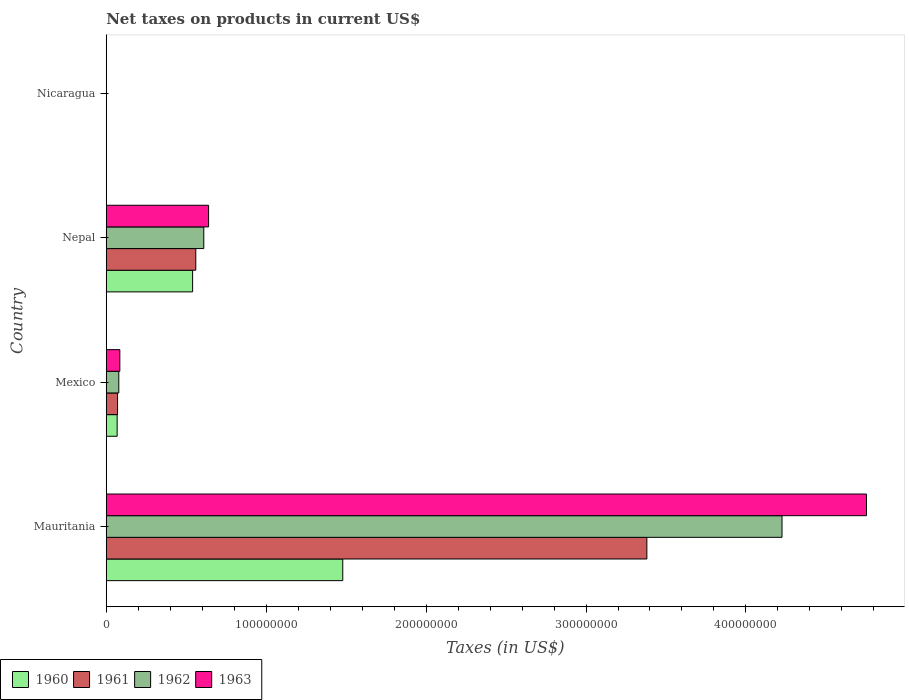How many different coloured bars are there?
Ensure brevity in your answer.  4. How many groups of bars are there?
Provide a short and direct response. 4. Are the number of bars on each tick of the Y-axis equal?
Your answer should be compact. Yes. How many bars are there on the 2nd tick from the bottom?
Offer a terse response. 4. What is the label of the 4th group of bars from the top?
Provide a succinct answer. Mauritania. What is the net taxes on products in 1962 in Nepal?
Offer a very short reply. 6.10e+07. Across all countries, what is the maximum net taxes on products in 1963?
Your answer should be compact. 4.75e+08. Across all countries, what is the minimum net taxes on products in 1963?
Ensure brevity in your answer.  0.04. In which country was the net taxes on products in 1961 maximum?
Provide a succinct answer. Mauritania. In which country was the net taxes on products in 1961 minimum?
Provide a succinct answer. Nicaragua. What is the total net taxes on products in 1962 in the graph?
Keep it short and to the point. 4.91e+08. What is the difference between the net taxes on products in 1960 in Mauritania and that in Mexico?
Make the answer very short. 1.41e+08. What is the difference between the net taxes on products in 1963 in Mauritania and the net taxes on products in 1961 in Nepal?
Offer a very short reply. 4.19e+08. What is the average net taxes on products in 1961 per country?
Your response must be concise. 1.00e+08. What is the difference between the net taxes on products in 1961 and net taxes on products in 1960 in Mauritania?
Make the answer very short. 1.90e+08. In how many countries, is the net taxes on products in 1963 greater than 240000000 US$?
Keep it short and to the point. 1. What is the ratio of the net taxes on products in 1963 in Mauritania to that in Nicaragua?
Offer a very short reply. 1.14e+1. Is the net taxes on products in 1963 in Mexico less than that in Nepal?
Provide a short and direct response. Yes. Is the difference between the net taxes on products in 1961 in Mexico and Nicaragua greater than the difference between the net taxes on products in 1960 in Mexico and Nicaragua?
Keep it short and to the point. Yes. What is the difference between the highest and the second highest net taxes on products in 1960?
Your answer should be very brief. 9.39e+07. What is the difference between the highest and the lowest net taxes on products in 1961?
Your answer should be compact. 3.38e+08. Is the sum of the net taxes on products in 1961 in Mexico and Nicaragua greater than the maximum net taxes on products in 1963 across all countries?
Offer a terse response. No. What does the 4th bar from the bottom in Mauritania represents?
Ensure brevity in your answer.  1963. How many countries are there in the graph?
Provide a short and direct response. 4. What is the difference between two consecutive major ticks on the X-axis?
Keep it short and to the point. 1.00e+08. Are the values on the major ticks of X-axis written in scientific E-notation?
Offer a terse response. No. Where does the legend appear in the graph?
Your answer should be compact. Bottom left. How are the legend labels stacked?
Offer a terse response. Horizontal. What is the title of the graph?
Keep it short and to the point. Net taxes on products in current US$. What is the label or title of the X-axis?
Provide a succinct answer. Taxes (in US$). What is the Taxes (in US$) in 1960 in Mauritania?
Keep it short and to the point. 1.48e+08. What is the Taxes (in US$) of 1961 in Mauritania?
Offer a terse response. 3.38e+08. What is the Taxes (in US$) of 1962 in Mauritania?
Give a very brief answer. 4.23e+08. What is the Taxes (in US$) of 1963 in Mauritania?
Provide a short and direct response. 4.75e+08. What is the Taxes (in US$) in 1960 in Mexico?
Provide a succinct answer. 6.81e+06. What is the Taxes (in US$) in 1961 in Mexico?
Give a very brief answer. 7.08e+06. What is the Taxes (in US$) in 1962 in Mexico?
Offer a terse response. 7.85e+06. What is the Taxes (in US$) in 1963 in Mexico?
Ensure brevity in your answer.  8.49e+06. What is the Taxes (in US$) of 1960 in Nepal?
Keep it short and to the point. 5.40e+07. What is the Taxes (in US$) in 1961 in Nepal?
Your response must be concise. 5.60e+07. What is the Taxes (in US$) in 1962 in Nepal?
Keep it short and to the point. 6.10e+07. What is the Taxes (in US$) of 1963 in Nepal?
Your response must be concise. 6.40e+07. What is the Taxes (in US$) of 1960 in Nicaragua?
Ensure brevity in your answer.  0.03. What is the Taxes (in US$) of 1961 in Nicaragua?
Offer a very short reply. 0.03. What is the Taxes (in US$) of 1962 in Nicaragua?
Provide a succinct answer. 0.04. What is the Taxes (in US$) of 1963 in Nicaragua?
Keep it short and to the point. 0.04. Across all countries, what is the maximum Taxes (in US$) of 1960?
Offer a terse response. 1.48e+08. Across all countries, what is the maximum Taxes (in US$) in 1961?
Offer a terse response. 3.38e+08. Across all countries, what is the maximum Taxes (in US$) of 1962?
Ensure brevity in your answer.  4.23e+08. Across all countries, what is the maximum Taxes (in US$) of 1963?
Keep it short and to the point. 4.75e+08. Across all countries, what is the minimum Taxes (in US$) of 1960?
Your response must be concise. 0.03. Across all countries, what is the minimum Taxes (in US$) of 1961?
Ensure brevity in your answer.  0.03. Across all countries, what is the minimum Taxes (in US$) of 1962?
Your response must be concise. 0.04. Across all countries, what is the minimum Taxes (in US$) of 1963?
Offer a very short reply. 0.04. What is the total Taxes (in US$) in 1960 in the graph?
Ensure brevity in your answer.  2.09e+08. What is the total Taxes (in US$) in 1961 in the graph?
Offer a terse response. 4.01e+08. What is the total Taxes (in US$) in 1962 in the graph?
Your answer should be very brief. 4.91e+08. What is the total Taxes (in US$) in 1963 in the graph?
Ensure brevity in your answer.  5.48e+08. What is the difference between the Taxes (in US$) of 1960 in Mauritania and that in Mexico?
Offer a terse response. 1.41e+08. What is the difference between the Taxes (in US$) in 1961 in Mauritania and that in Mexico?
Your answer should be compact. 3.31e+08. What is the difference between the Taxes (in US$) of 1962 in Mauritania and that in Mexico?
Your answer should be compact. 4.15e+08. What is the difference between the Taxes (in US$) of 1963 in Mauritania and that in Mexico?
Keep it short and to the point. 4.67e+08. What is the difference between the Taxes (in US$) of 1960 in Mauritania and that in Nepal?
Provide a succinct answer. 9.39e+07. What is the difference between the Taxes (in US$) in 1961 in Mauritania and that in Nepal?
Keep it short and to the point. 2.82e+08. What is the difference between the Taxes (in US$) in 1962 in Mauritania and that in Nepal?
Keep it short and to the point. 3.62e+08. What is the difference between the Taxes (in US$) of 1963 in Mauritania and that in Nepal?
Offer a very short reply. 4.11e+08. What is the difference between the Taxes (in US$) in 1960 in Mauritania and that in Nicaragua?
Provide a succinct answer. 1.48e+08. What is the difference between the Taxes (in US$) of 1961 in Mauritania and that in Nicaragua?
Provide a succinct answer. 3.38e+08. What is the difference between the Taxes (in US$) in 1962 in Mauritania and that in Nicaragua?
Your answer should be compact. 4.23e+08. What is the difference between the Taxes (in US$) of 1963 in Mauritania and that in Nicaragua?
Keep it short and to the point. 4.75e+08. What is the difference between the Taxes (in US$) of 1960 in Mexico and that in Nepal?
Offer a very short reply. -4.72e+07. What is the difference between the Taxes (in US$) of 1961 in Mexico and that in Nepal?
Provide a short and direct response. -4.89e+07. What is the difference between the Taxes (in US$) of 1962 in Mexico and that in Nepal?
Make the answer very short. -5.32e+07. What is the difference between the Taxes (in US$) in 1963 in Mexico and that in Nepal?
Provide a succinct answer. -5.55e+07. What is the difference between the Taxes (in US$) in 1960 in Mexico and that in Nicaragua?
Provide a short and direct response. 6.81e+06. What is the difference between the Taxes (in US$) in 1961 in Mexico and that in Nicaragua?
Make the answer very short. 7.08e+06. What is the difference between the Taxes (in US$) of 1962 in Mexico and that in Nicaragua?
Ensure brevity in your answer.  7.85e+06. What is the difference between the Taxes (in US$) of 1963 in Mexico and that in Nicaragua?
Your response must be concise. 8.49e+06. What is the difference between the Taxes (in US$) of 1960 in Nepal and that in Nicaragua?
Provide a succinct answer. 5.40e+07. What is the difference between the Taxes (in US$) in 1961 in Nepal and that in Nicaragua?
Provide a succinct answer. 5.60e+07. What is the difference between the Taxes (in US$) in 1962 in Nepal and that in Nicaragua?
Keep it short and to the point. 6.10e+07. What is the difference between the Taxes (in US$) of 1963 in Nepal and that in Nicaragua?
Your answer should be very brief. 6.40e+07. What is the difference between the Taxes (in US$) in 1960 in Mauritania and the Taxes (in US$) in 1961 in Mexico?
Provide a short and direct response. 1.41e+08. What is the difference between the Taxes (in US$) in 1960 in Mauritania and the Taxes (in US$) in 1962 in Mexico?
Your response must be concise. 1.40e+08. What is the difference between the Taxes (in US$) in 1960 in Mauritania and the Taxes (in US$) in 1963 in Mexico?
Your response must be concise. 1.39e+08. What is the difference between the Taxes (in US$) of 1961 in Mauritania and the Taxes (in US$) of 1962 in Mexico?
Your response must be concise. 3.30e+08. What is the difference between the Taxes (in US$) of 1961 in Mauritania and the Taxes (in US$) of 1963 in Mexico?
Offer a very short reply. 3.30e+08. What is the difference between the Taxes (in US$) in 1962 in Mauritania and the Taxes (in US$) in 1963 in Mexico?
Your answer should be compact. 4.14e+08. What is the difference between the Taxes (in US$) in 1960 in Mauritania and the Taxes (in US$) in 1961 in Nepal?
Give a very brief answer. 9.19e+07. What is the difference between the Taxes (in US$) of 1960 in Mauritania and the Taxes (in US$) of 1962 in Nepal?
Your answer should be compact. 8.69e+07. What is the difference between the Taxes (in US$) in 1960 in Mauritania and the Taxes (in US$) in 1963 in Nepal?
Make the answer very short. 8.39e+07. What is the difference between the Taxes (in US$) of 1961 in Mauritania and the Taxes (in US$) of 1962 in Nepal?
Your response must be concise. 2.77e+08. What is the difference between the Taxes (in US$) of 1961 in Mauritania and the Taxes (in US$) of 1963 in Nepal?
Provide a succinct answer. 2.74e+08. What is the difference between the Taxes (in US$) of 1962 in Mauritania and the Taxes (in US$) of 1963 in Nepal?
Give a very brief answer. 3.59e+08. What is the difference between the Taxes (in US$) in 1960 in Mauritania and the Taxes (in US$) in 1961 in Nicaragua?
Keep it short and to the point. 1.48e+08. What is the difference between the Taxes (in US$) in 1960 in Mauritania and the Taxes (in US$) in 1962 in Nicaragua?
Keep it short and to the point. 1.48e+08. What is the difference between the Taxes (in US$) in 1960 in Mauritania and the Taxes (in US$) in 1963 in Nicaragua?
Your answer should be very brief. 1.48e+08. What is the difference between the Taxes (in US$) of 1961 in Mauritania and the Taxes (in US$) of 1962 in Nicaragua?
Give a very brief answer. 3.38e+08. What is the difference between the Taxes (in US$) of 1961 in Mauritania and the Taxes (in US$) of 1963 in Nicaragua?
Your answer should be very brief. 3.38e+08. What is the difference between the Taxes (in US$) of 1962 in Mauritania and the Taxes (in US$) of 1963 in Nicaragua?
Offer a very short reply. 4.23e+08. What is the difference between the Taxes (in US$) of 1960 in Mexico and the Taxes (in US$) of 1961 in Nepal?
Ensure brevity in your answer.  -4.92e+07. What is the difference between the Taxes (in US$) of 1960 in Mexico and the Taxes (in US$) of 1962 in Nepal?
Your response must be concise. -5.42e+07. What is the difference between the Taxes (in US$) of 1960 in Mexico and the Taxes (in US$) of 1963 in Nepal?
Provide a succinct answer. -5.72e+07. What is the difference between the Taxes (in US$) of 1961 in Mexico and the Taxes (in US$) of 1962 in Nepal?
Provide a short and direct response. -5.39e+07. What is the difference between the Taxes (in US$) in 1961 in Mexico and the Taxes (in US$) in 1963 in Nepal?
Make the answer very short. -5.69e+07. What is the difference between the Taxes (in US$) in 1962 in Mexico and the Taxes (in US$) in 1963 in Nepal?
Provide a short and direct response. -5.62e+07. What is the difference between the Taxes (in US$) in 1960 in Mexico and the Taxes (in US$) in 1961 in Nicaragua?
Provide a short and direct response. 6.81e+06. What is the difference between the Taxes (in US$) of 1960 in Mexico and the Taxes (in US$) of 1962 in Nicaragua?
Ensure brevity in your answer.  6.81e+06. What is the difference between the Taxes (in US$) in 1960 in Mexico and the Taxes (in US$) in 1963 in Nicaragua?
Your response must be concise. 6.81e+06. What is the difference between the Taxes (in US$) of 1961 in Mexico and the Taxes (in US$) of 1962 in Nicaragua?
Offer a very short reply. 7.08e+06. What is the difference between the Taxes (in US$) in 1961 in Mexico and the Taxes (in US$) in 1963 in Nicaragua?
Give a very brief answer. 7.08e+06. What is the difference between the Taxes (in US$) of 1962 in Mexico and the Taxes (in US$) of 1963 in Nicaragua?
Your answer should be very brief. 7.85e+06. What is the difference between the Taxes (in US$) in 1960 in Nepal and the Taxes (in US$) in 1961 in Nicaragua?
Make the answer very short. 5.40e+07. What is the difference between the Taxes (in US$) in 1960 in Nepal and the Taxes (in US$) in 1962 in Nicaragua?
Provide a short and direct response. 5.40e+07. What is the difference between the Taxes (in US$) of 1960 in Nepal and the Taxes (in US$) of 1963 in Nicaragua?
Provide a succinct answer. 5.40e+07. What is the difference between the Taxes (in US$) of 1961 in Nepal and the Taxes (in US$) of 1962 in Nicaragua?
Your answer should be very brief. 5.60e+07. What is the difference between the Taxes (in US$) in 1961 in Nepal and the Taxes (in US$) in 1963 in Nicaragua?
Ensure brevity in your answer.  5.60e+07. What is the difference between the Taxes (in US$) in 1962 in Nepal and the Taxes (in US$) in 1963 in Nicaragua?
Give a very brief answer. 6.10e+07. What is the average Taxes (in US$) in 1960 per country?
Provide a short and direct response. 5.22e+07. What is the average Taxes (in US$) of 1961 per country?
Offer a very short reply. 1.00e+08. What is the average Taxes (in US$) of 1962 per country?
Give a very brief answer. 1.23e+08. What is the average Taxes (in US$) in 1963 per country?
Ensure brevity in your answer.  1.37e+08. What is the difference between the Taxes (in US$) in 1960 and Taxes (in US$) in 1961 in Mauritania?
Ensure brevity in your answer.  -1.90e+08. What is the difference between the Taxes (in US$) in 1960 and Taxes (in US$) in 1962 in Mauritania?
Your response must be concise. -2.75e+08. What is the difference between the Taxes (in US$) of 1960 and Taxes (in US$) of 1963 in Mauritania?
Keep it short and to the point. -3.27e+08. What is the difference between the Taxes (in US$) of 1961 and Taxes (in US$) of 1962 in Mauritania?
Make the answer very short. -8.45e+07. What is the difference between the Taxes (in US$) of 1961 and Taxes (in US$) of 1963 in Mauritania?
Ensure brevity in your answer.  -1.37e+08. What is the difference between the Taxes (in US$) of 1962 and Taxes (in US$) of 1963 in Mauritania?
Offer a terse response. -5.28e+07. What is the difference between the Taxes (in US$) in 1960 and Taxes (in US$) in 1961 in Mexico?
Provide a short and direct response. -2.73e+05. What is the difference between the Taxes (in US$) of 1960 and Taxes (in US$) of 1962 in Mexico?
Keep it short and to the point. -1.04e+06. What is the difference between the Taxes (in US$) of 1960 and Taxes (in US$) of 1963 in Mexico?
Your answer should be very brief. -1.69e+06. What is the difference between the Taxes (in US$) in 1961 and Taxes (in US$) in 1962 in Mexico?
Your answer should be compact. -7.69e+05. What is the difference between the Taxes (in US$) in 1961 and Taxes (in US$) in 1963 in Mexico?
Ensure brevity in your answer.  -1.41e+06. What is the difference between the Taxes (in US$) of 1962 and Taxes (in US$) of 1963 in Mexico?
Provide a short and direct response. -6.43e+05. What is the difference between the Taxes (in US$) of 1960 and Taxes (in US$) of 1962 in Nepal?
Give a very brief answer. -7.00e+06. What is the difference between the Taxes (in US$) of 1960 and Taxes (in US$) of 1963 in Nepal?
Give a very brief answer. -1.00e+07. What is the difference between the Taxes (in US$) of 1961 and Taxes (in US$) of 1962 in Nepal?
Provide a succinct answer. -5.00e+06. What is the difference between the Taxes (in US$) in 1961 and Taxes (in US$) in 1963 in Nepal?
Offer a terse response. -8.00e+06. What is the difference between the Taxes (in US$) of 1962 and Taxes (in US$) of 1963 in Nepal?
Ensure brevity in your answer.  -3.00e+06. What is the difference between the Taxes (in US$) in 1960 and Taxes (in US$) in 1961 in Nicaragua?
Give a very brief answer. -0. What is the difference between the Taxes (in US$) of 1960 and Taxes (in US$) of 1962 in Nicaragua?
Your answer should be compact. -0.01. What is the difference between the Taxes (in US$) in 1960 and Taxes (in US$) in 1963 in Nicaragua?
Your response must be concise. -0.01. What is the difference between the Taxes (in US$) of 1961 and Taxes (in US$) of 1962 in Nicaragua?
Your answer should be compact. -0. What is the difference between the Taxes (in US$) of 1961 and Taxes (in US$) of 1963 in Nicaragua?
Your response must be concise. -0.01. What is the difference between the Taxes (in US$) of 1962 and Taxes (in US$) of 1963 in Nicaragua?
Your answer should be very brief. -0.01. What is the ratio of the Taxes (in US$) in 1960 in Mauritania to that in Mexico?
Keep it short and to the point. 21.73. What is the ratio of the Taxes (in US$) in 1961 in Mauritania to that in Mexico?
Offer a terse response. 47.75. What is the ratio of the Taxes (in US$) in 1962 in Mauritania to that in Mexico?
Give a very brief answer. 53.84. What is the ratio of the Taxes (in US$) of 1963 in Mauritania to that in Mexico?
Provide a short and direct response. 55.98. What is the ratio of the Taxes (in US$) of 1960 in Mauritania to that in Nepal?
Provide a succinct answer. 2.74. What is the ratio of the Taxes (in US$) in 1961 in Mauritania to that in Nepal?
Provide a short and direct response. 6.04. What is the ratio of the Taxes (in US$) in 1962 in Mauritania to that in Nepal?
Your response must be concise. 6.93. What is the ratio of the Taxes (in US$) in 1963 in Mauritania to that in Nepal?
Offer a terse response. 7.43. What is the ratio of the Taxes (in US$) of 1960 in Mauritania to that in Nicaragua?
Provide a short and direct response. 4.97e+09. What is the ratio of the Taxes (in US$) of 1961 in Mauritania to that in Nicaragua?
Your response must be concise. 1.09e+1. What is the ratio of the Taxes (in US$) of 1962 in Mauritania to that in Nicaragua?
Offer a terse response. 1.20e+1. What is the ratio of the Taxes (in US$) of 1963 in Mauritania to that in Nicaragua?
Ensure brevity in your answer.  1.14e+1. What is the ratio of the Taxes (in US$) in 1960 in Mexico to that in Nepal?
Offer a very short reply. 0.13. What is the ratio of the Taxes (in US$) of 1961 in Mexico to that in Nepal?
Offer a very short reply. 0.13. What is the ratio of the Taxes (in US$) of 1962 in Mexico to that in Nepal?
Your answer should be compact. 0.13. What is the ratio of the Taxes (in US$) in 1963 in Mexico to that in Nepal?
Your answer should be very brief. 0.13. What is the ratio of the Taxes (in US$) of 1960 in Mexico to that in Nicaragua?
Keep it short and to the point. 2.29e+08. What is the ratio of the Taxes (in US$) in 1961 in Mexico to that in Nicaragua?
Offer a very short reply. 2.27e+08. What is the ratio of the Taxes (in US$) of 1962 in Mexico to that in Nicaragua?
Keep it short and to the point. 2.22e+08. What is the ratio of the Taxes (in US$) in 1963 in Mexico to that in Nicaragua?
Offer a very short reply. 2.04e+08. What is the ratio of the Taxes (in US$) in 1960 in Nepal to that in Nicaragua?
Your response must be concise. 1.81e+09. What is the ratio of the Taxes (in US$) of 1961 in Nepal to that in Nicaragua?
Your response must be concise. 1.80e+09. What is the ratio of the Taxes (in US$) in 1962 in Nepal to that in Nicaragua?
Keep it short and to the point. 1.73e+09. What is the ratio of the Taxes (in US$) of 1963 in Nepal to that in Nicaragua?
Provide a short and direct response. 1.54e+09. What is the difference between the highest and the second highest Taxes (in US$) in 1960?
Offer a very short reply. 9.39e+07. What is the difference between the highest and the second highest Taxes (in US$) of 1961?
Give a very brief answer. 2.82e+08. What is the difference between the highest and the second highest Taxes (in US$) of 1962?
Make the answer very short. 3.62e+08. What is the difference between the highest and the second highest Taxes (in US$) of 1963?
Offer a terse response. 4.11e+08. What is the difference between the highest and the lowest Taxes (in US$) in 1960?
Ensure brevity in your answer.  1.48e+08. What is the difference between the highest and the lowest Taxes (in US$) of 1961?
Keep it short and to the point. 3.38e+08. What is the difference between the highest and the lowest Taxes (in US$) in 1962?
Offer a terse response. 4.23e+08. What is the difference between the highest and the lowest Taxes (in US$) in 1963?
Provide a succinct answer. 4.75e+08. 